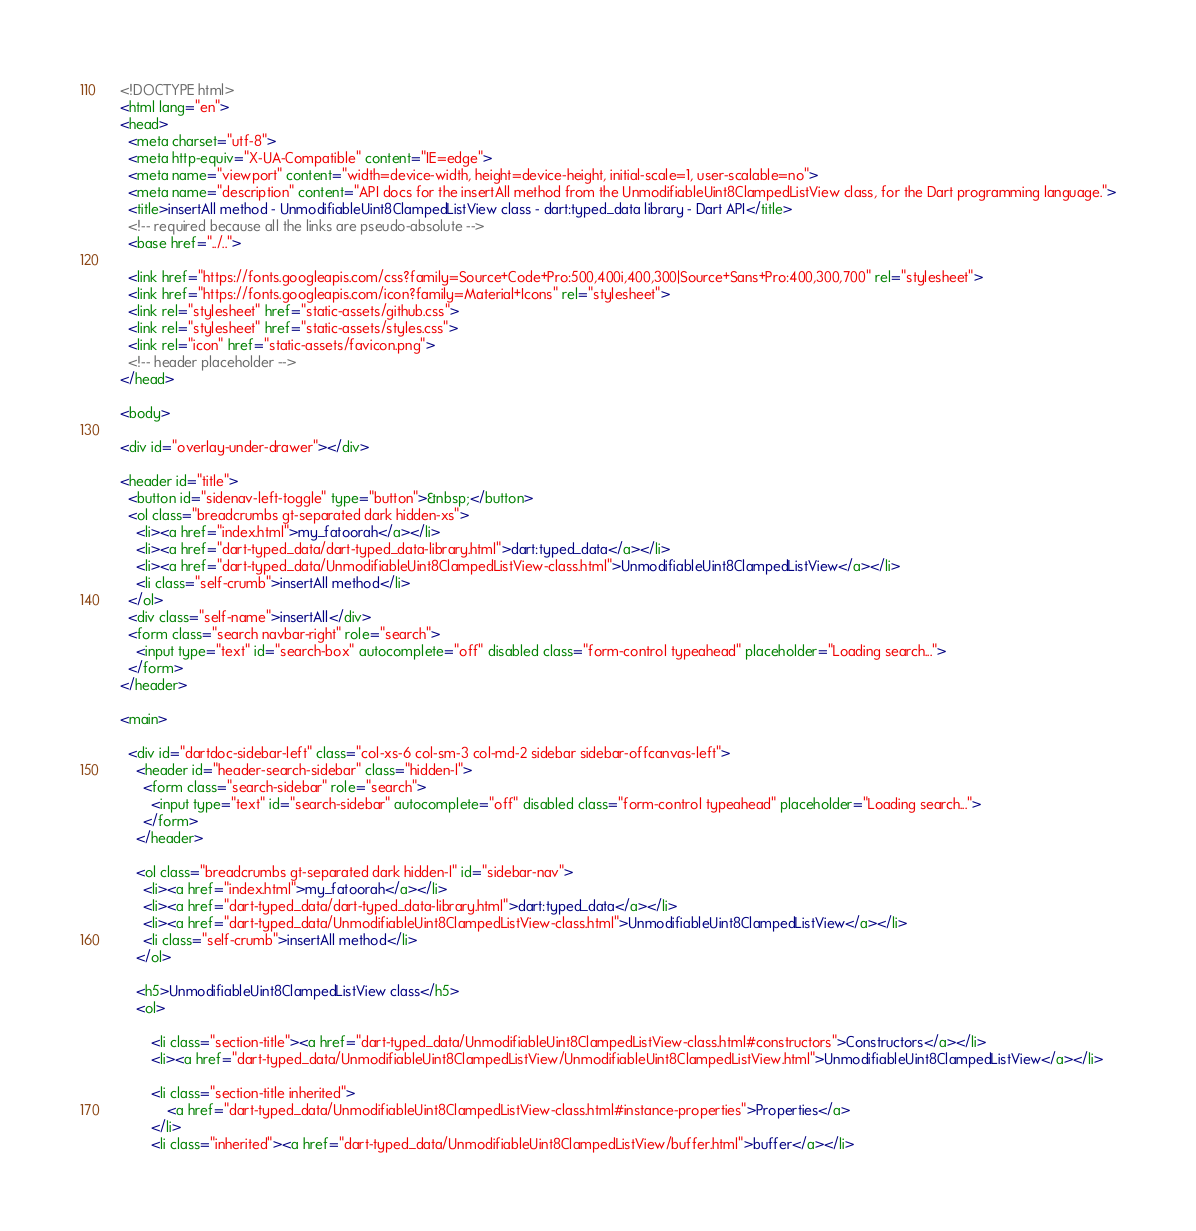<code> <loc_0><loc_0><loc_500><loc_500><_HTML_><!DOCTYPE html>
<html lang="en">
<head>
  <meta charset="utf-8">
  <meta http-equiv="X-UA-Compatible" content="IE=edge">
  <meta name="viewport" content="width=device-width, height=device-height, initial-scale=1, user-scalable=no">
  <meta name="description" content="API docs for the insertAll method from the UnmodifiableUint8ClampedListView class, for the Dart programming language.">
  <title>insertAll method - UnmodifiableUint8ClampedListView class - dart:typed_data library - Dart API</title>
  <!-- required because all the links are pseudo-absolute -->
  <base href="../..">

  <link href="https://fonts.googleapis.com/css?family=Source+Code+Pro:500,400i,400,300|Source+Sans+Pro:400,300,700" rel="stylesheet">
  <link href="https://fonts.googleapis.com/icon?family=Material+Icons" rel="stylesheet">
  <link rel="stylesheet" href="static-assets/github.css">
  <link rel="stylesheet" href="static-assets/styles.css">
  <link rel="icon" href="static-assets/favicon.png">
  <!-- header placeholder -->
</head>

<body>

<div id="overlay-under-drawer"></div>

<header id="title">
  <button id="sidenav-left-toggle" type="button">&nbsp;</button>
  <ol class="breadcrumbs gt-separated dark hidden-xs">
    <li><a href="index.html">my_fatoorah</a></li>
    <li><a href="dart-typed_data/dart-typed_data-library.html">dart:typed_data</a></li>
    <li><a href="dart-typed_data/UnmodifiableUint8ClampedListView-class.html">UnmodifiableUint8ClampedListView</a></li>
    <li class="self-crumb">insertAll method</li>
  </ol>
  <div class="self-name">insertAll</div>
  <form class="search navbar-right" role="search">
    <input type="text" id="search-box" autocomplete="off" disabled class="form-control typeahead" placeholder="Loading search...">
  </form>
</header>

<main>

  <div id="dartdoc-sidebar-left" class="col-xs-6 col-sm-3 col-md-2 sidebar sidebar-offcanvas-left">
    <header id="header-search-sidebar" class="hidden-l">
      <form class="search-sidebar" role="search">
        <input type="text" id="search-sidebar" autocomplete="off" disabled class="form-control typeahead" placeholder="Loading search...">
      </form>
    </header>
    
    <ol class="breadcrumbs gt-separated dark hidden-l" id="sidebar-nav">
      <li><a href="index.html">my_fatoorah</a></li>
      <li><a href="dart-typed_data/dart-typed_data-library.html">dart:typed_data</a></li>
      <li><a href="dart-typed_data/UnmodifiableUint8ClampedListView-class.html">UnmodifiableUint8ClampedListView</a></li>
      <li class="self-crumb">insertAll method</li>
    </ol>
    
    <h5>UnmodifiableUint8ClampedListView class</h5>
    <ol>
    
        <li class="section-title"><a href="dart-typed_data/UnmodifiableUint8ClampedListView-class.html#constructors">Constructors</a></li>
        <li><a href="dart-typed_data/UnmodifiableUint8ClampedListView/UnmodifiableUint8ClampedListView.html">UnmodifiableUint8ClampedListView</a></li>
    
        <li class="section-title inherited">
            <a href="dart-typed_data/UnmodifiableUint8ClampedListView-class.html#instance-properties">Properties</a>
        </li>
        <li class="inherited"><a href="dart-typed_data/UnmodifiableUint8ClampedListView/buffer.html">buffer</a></li></code> 